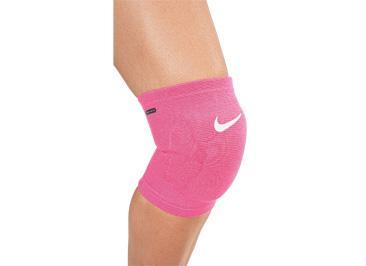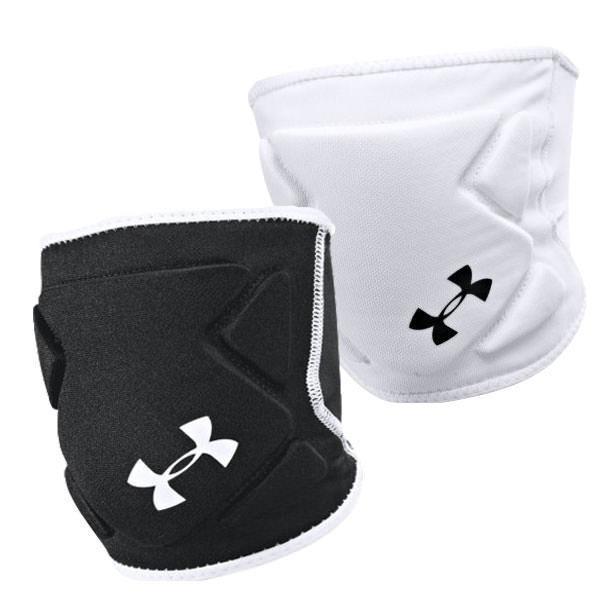The first image is the image on the left, the second image is the image on the right. Examine the images to the left and right. Is the description "Together, the images include both white knee pads and black knee pads only." accurate? Answer yes or no. No. 